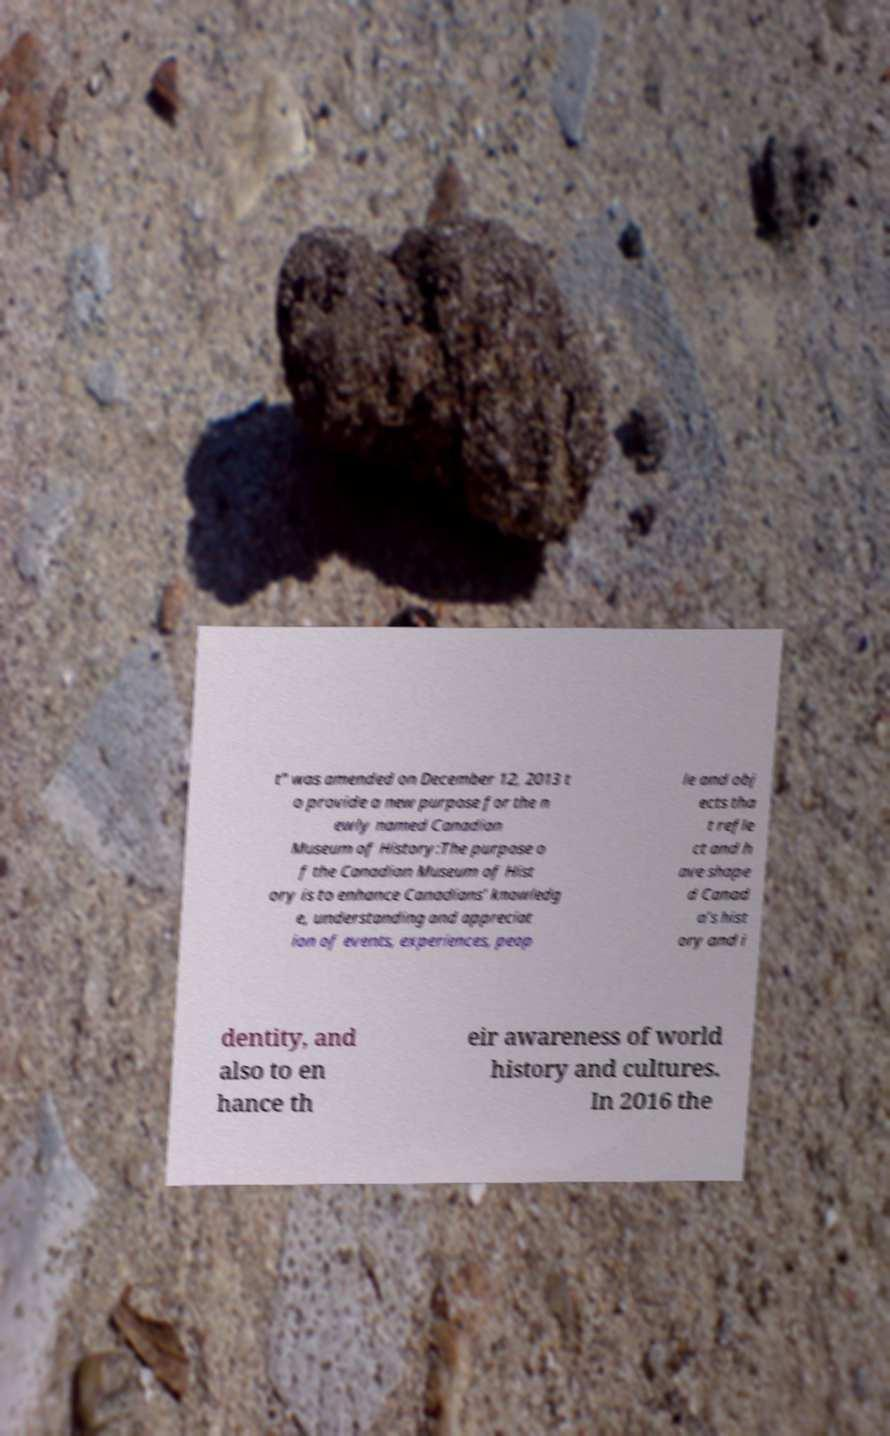I need the written content from this picture converted into text. Can you do that? t" was amended on December 12, 2013 t o provide a new purpose for the n ewly named Canadian Museum of History:The purpose o f the Canadian Museum of Hist ory is to enhance Canadians’ knowledg e, understanding and appreciat ion of events, experiences, peop le and obj ects tha t refle ct and h ave shape d Canad a’s hist ory and i dentity, and also to en hance th eir awareness of world history and cultures. In 2016 the 